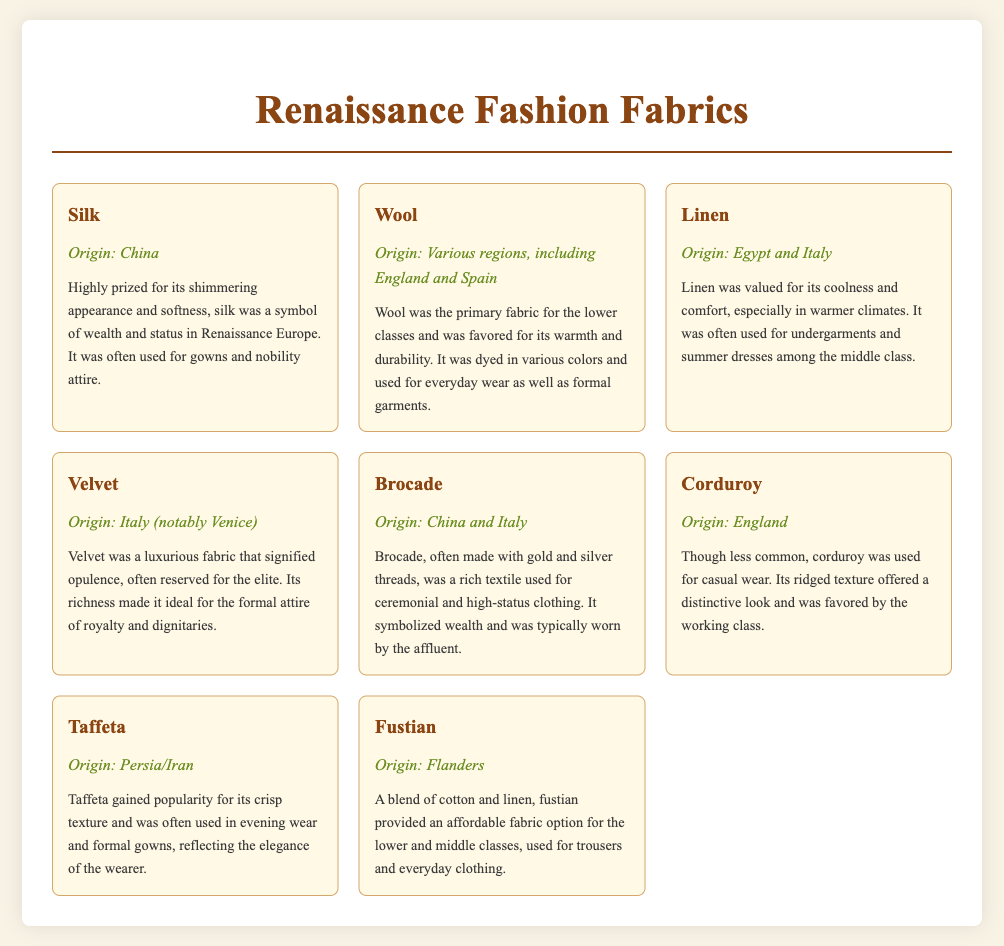What is the origin of Silk? Silk's origin is mentioned as China in the document.
Answer: China Which fabric was primarily used by the lower classes? The document states that wool was the primary fabric for the lower classes.
Answer: Wool What fabric is known for its shimmering appearance? The document highlights silk as being highly prized for its shimmering appearance.
Answer: Silk Which fabric was often used for undergarments and summer dresses? Linen is specified in the document as being often used for undergarments and summer dresses.
Answer: Linen What is the significance of Brocade? Brocade is indicated in the document as a rich textile that symbolized wealth.
Answer: Symbolized wealth What is the origin of Velvet? The document lists Italy, specifically Venice, as the origin of velvet.
Answer: Italy (notably Venice) What unique characteristic does Corduroy have? The document states that corduroy has a ridged texture, offering a distinctive look.
Answer: Ridged texture Which fabric was made with gold and silver threads? Brocade is mentioned in the document as often being made with gold and silver threads.
Answer: Brocade 